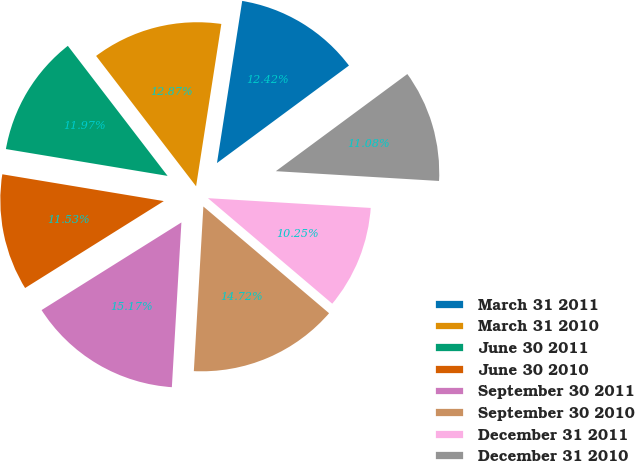Convert chart to OTSL. <chart><loc_0><loc_0><loc_500><loc_500><pie_chart><fcel>March 31 2011<fcel>March 31 2010<fcel>June 30 2011<fcel>June 30 2010<fcel>September 30 2011<fcel>September 30 2010<fcel>December 31 2011<fcel>December 31 2010<nl><fcel>12.42%<fcel>12.87%<fcel>11.97%<fcel>11.53%<fcel>15.17%<fcel>14.72%<fcel>10.25%<fcel>11.08%<nl></chart> 